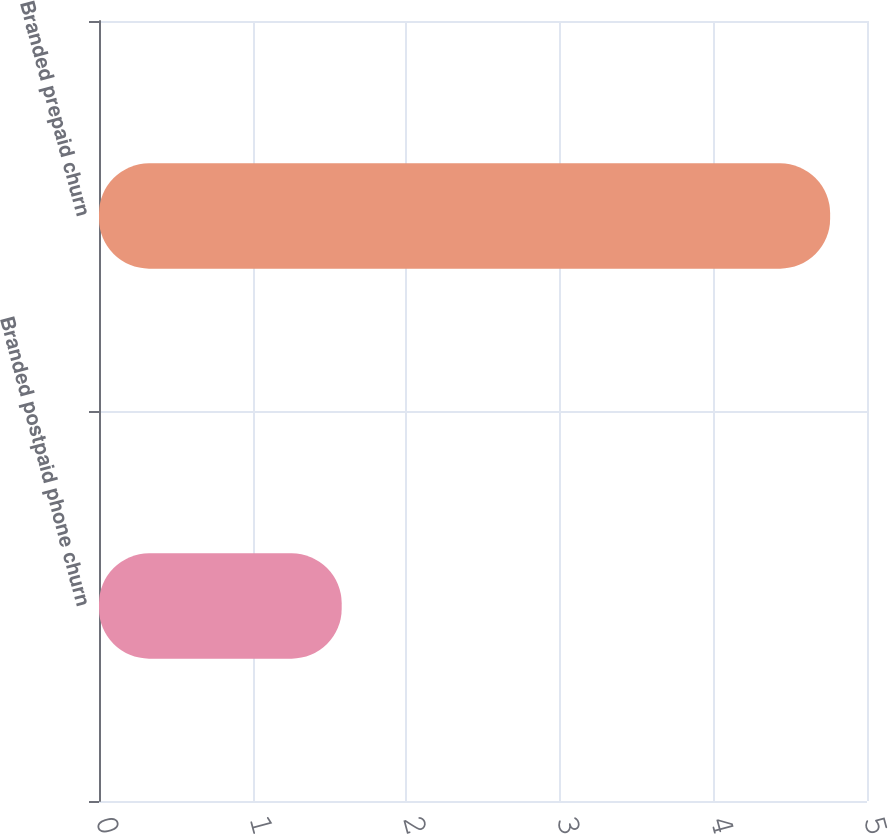Convert chart. <chart><loc_0><loc_0><loc_500><loc_500><bar_chart><fcel>Branded postpaid phone churn<fcel>Branded prepaid churn<nl><fcel>1.58<fcel>4.76<nl></chart> 